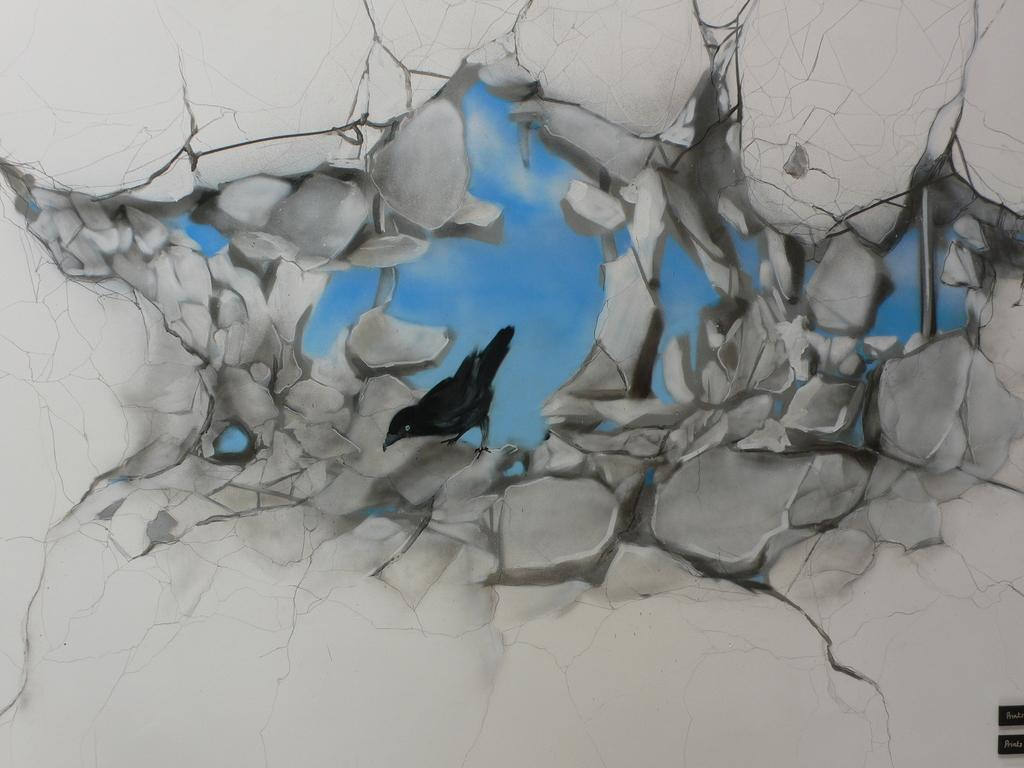What type of animal can be seen in the image? There is a bird in the image. Where is the bird located in the image? The bird is in the middle of the image. What color is the bird? The bird is black in color. What is visible in the background of the image? There is sky visible in the image. What type of skin condition does the bird have in the image? There is no indication of a skin condition on the bird in the image, as it is a black bird with no visible abnormalities. 